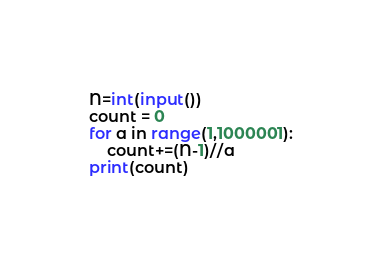Convert code to text. <code><loc_0><loc_0><loc_500><loc_500><_Python_>N=int(input())
count = 0
for a in range(1,1000001):
	count+=(N-1)//a
print(count)</code> 